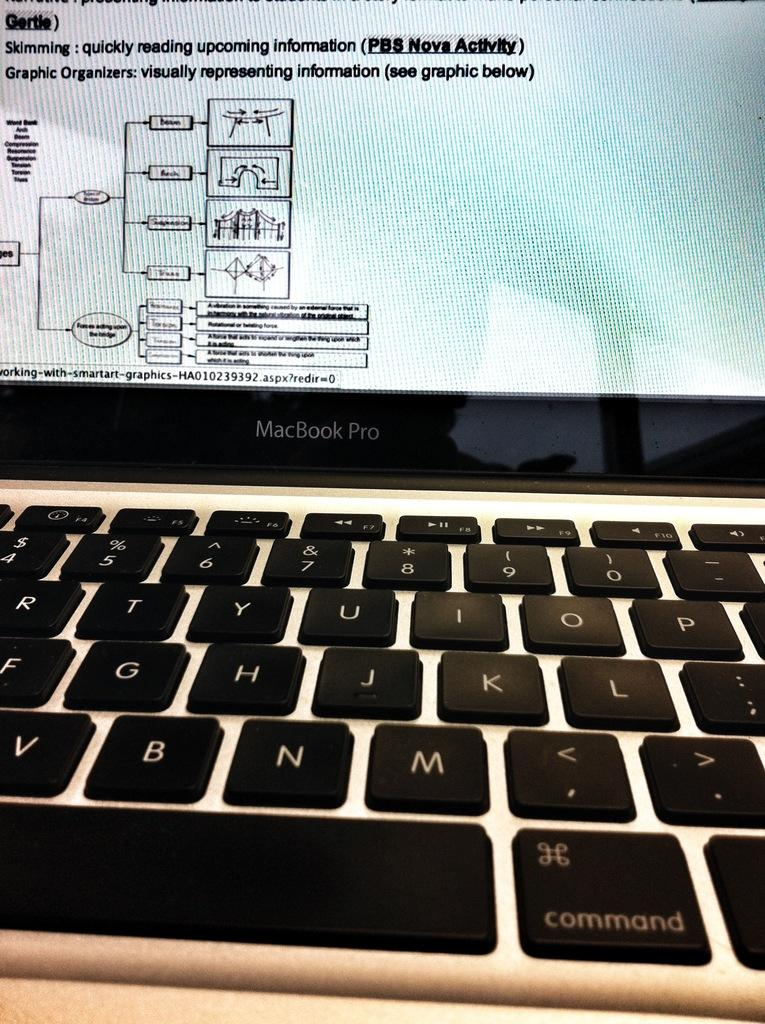<image>
Relay a brief, clear account of the picture shown. A MacBook Pro is displaying definitions of skimming and graphic organizers. 